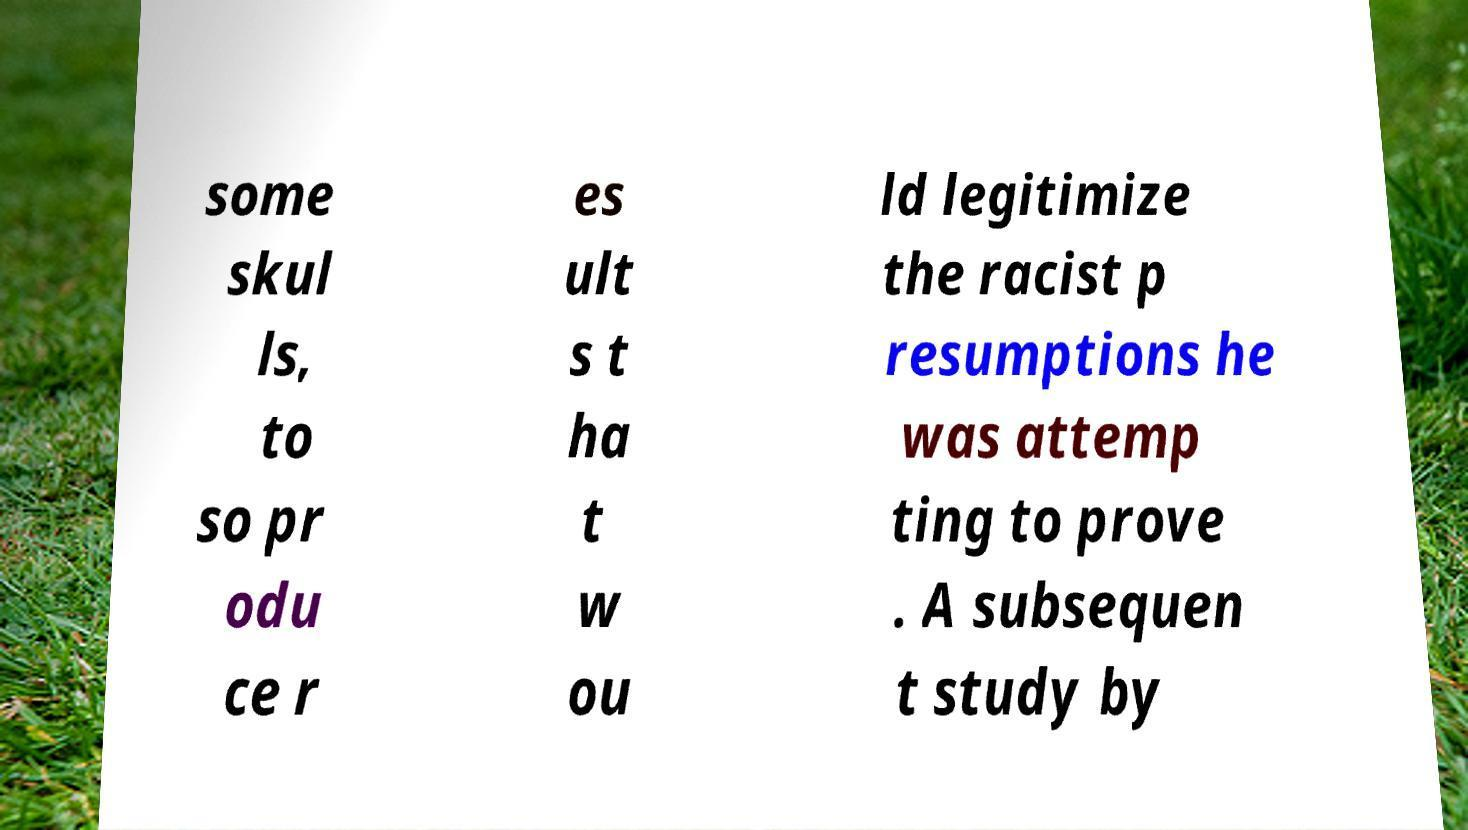Could you assist in decoding the text presented in this image and type it out clearly? some skul ls, to so pr odu ce r es ult s t ha t w ou ld legitimize the racist p resumptions he was attemp ting to prove . A subsequen t study by 